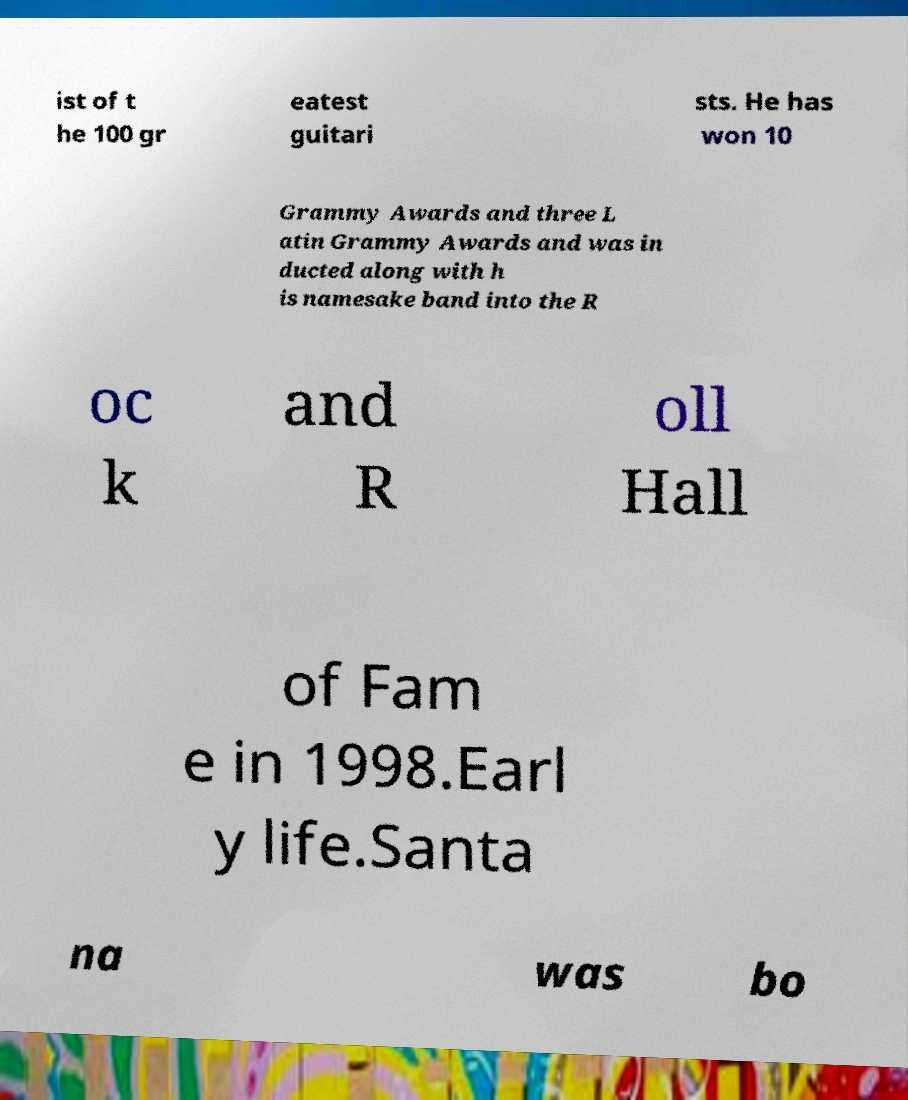Could you extract and type out the text from this image? ist of t he 100 gr eatest guitari sts. He has won 10 Grammy Awards and three L atin Grammy Awards and was in ducted along with h is namesake band into the R oc k and R oll Hall of Fam e in 1998.Earl y life.Santa na was bo 